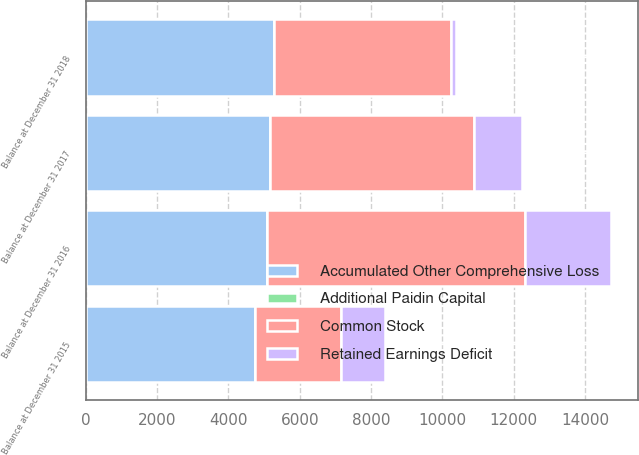Convert chart to OTSL. <chart><loc_0><loc_0><loc_500><loc_500><stacked_bar_chart><ecel><fcel>Balance at December 31 2015<fcel>Balance at December 31 2016<fcel>Balance at December 31 2017<fcel>Balance at December 31 2018<nl><fcel>Additional Paidin Capital<fcel>6<fcel>5<fcel>5<fcel>5<nl><fcel>Common Stock<fcel>2429<fcel>7223<fcel>5714<fcel>4964<nl><fcel>Accumulated Other Comprehensive Loss<fcel>4732<fcel>5083<fcel>5154<fcel>5274<nl><fcel>Retained Earnings Deficit<fcel>1230<fcel>2429<fcel>1345<fcel>136<nl></chart> 